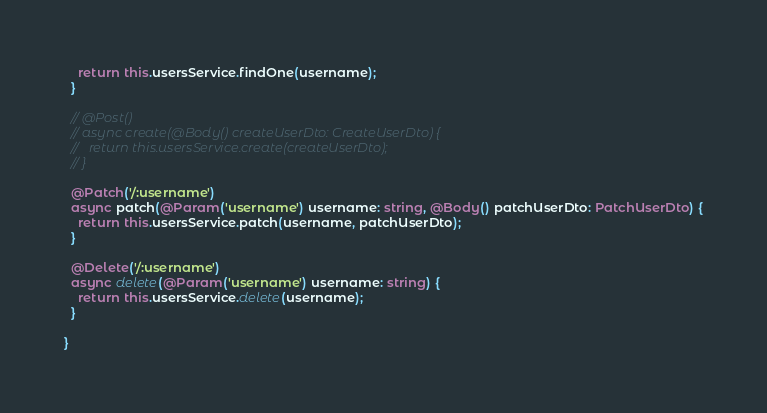<code> <loc_0><loc_0><loc_500><loc_500><_TypeScript_>    return this.usersService.findOne(username);
  }

  // @Post()
  // async create(@Body() createUserDto: CreateUserDto) {
  //   return this.usersService.create(createUserDto);
  // }

  @Patch('/:username')
  async patch(@Param('username') username: string, @Body() patchUserDto: PatchUserDto) {
    return this.usersService.patch(username, patchUserDto);
  }

  @Delete('/:username')
  async delete(@Param('username') username: string) {
    return this.usersService.delete(username);
  }

}
</code> 